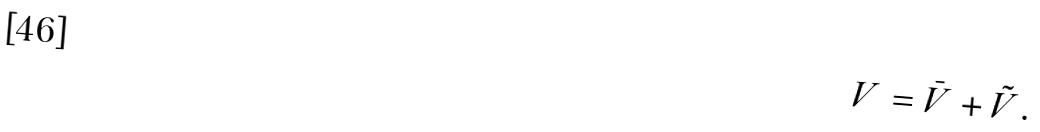Convert formula to latex. <formula><loc_0><loc_0><loc_500><loc_500>V = \bar { V } + \tilde { V } .</formula> 